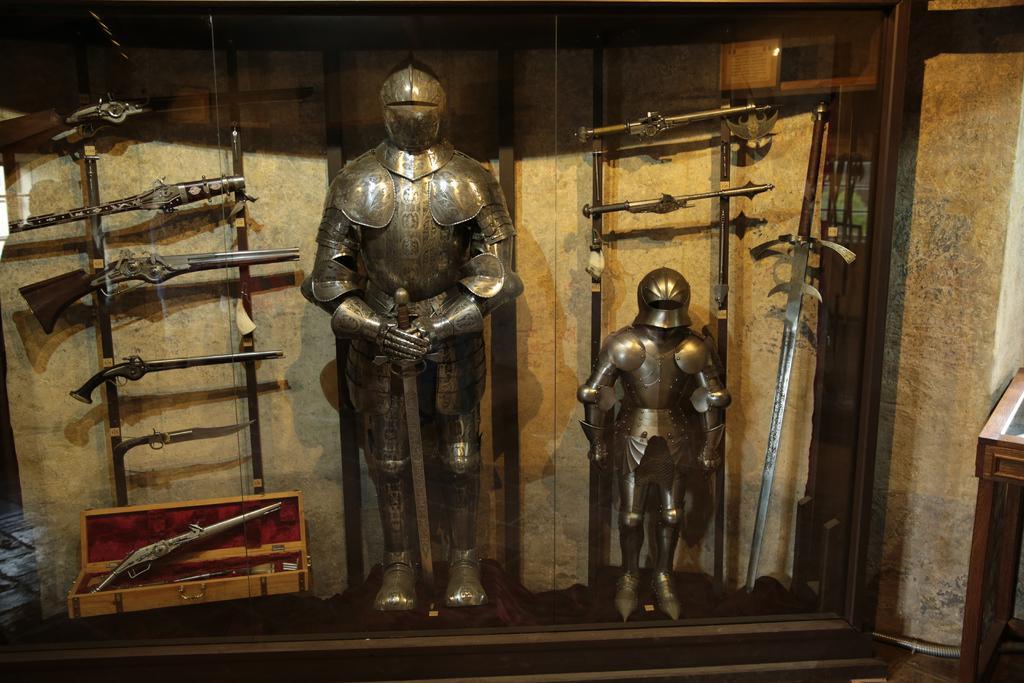Could you give a brief overview of what you see in this image? Here we can see statues, weapons, and a box. In the background there is a wall. 